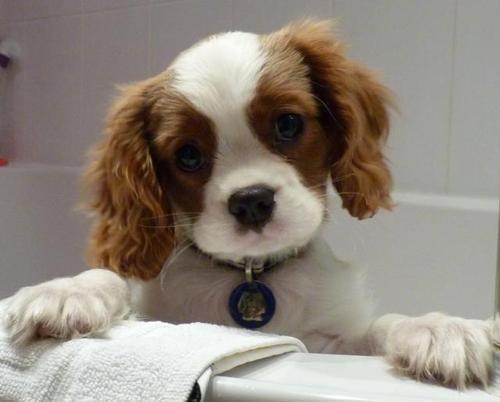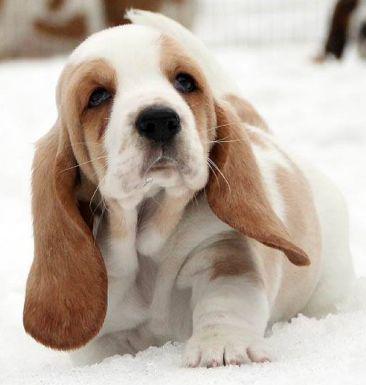The first image is the image on the left, the second image is the image on the right. Considering the images on both sides, is "There is a small puppy with brown floppy ears sitting on white snow." valid? Answer yes or no. Yes. 